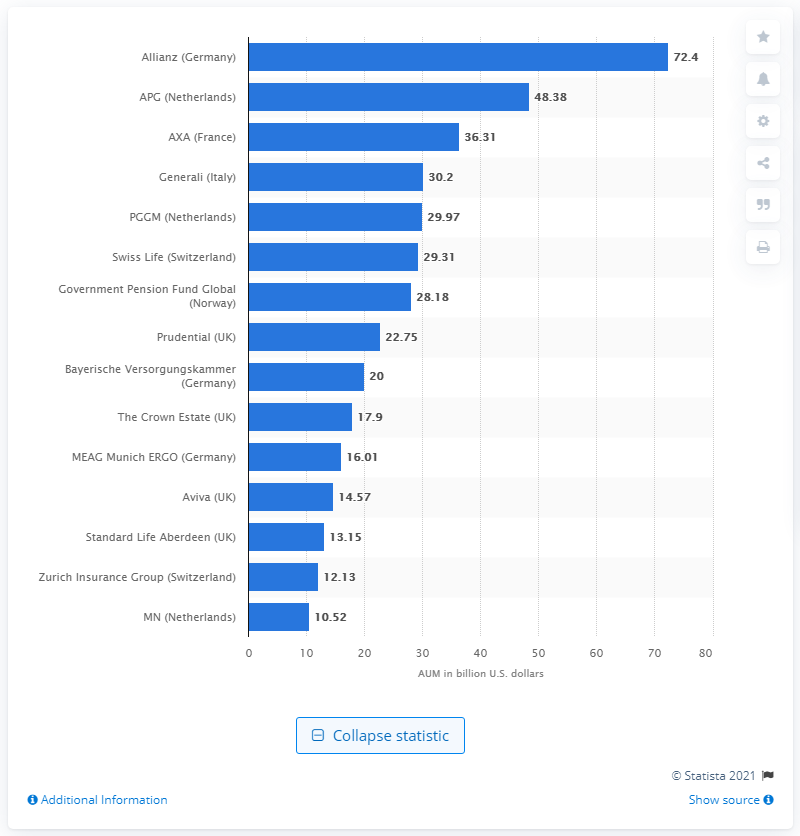Identify some key points in this picture. APG, the Dutch pension fund, had an average market value of assets under management (AUM) of 48.38 during the specified period. 